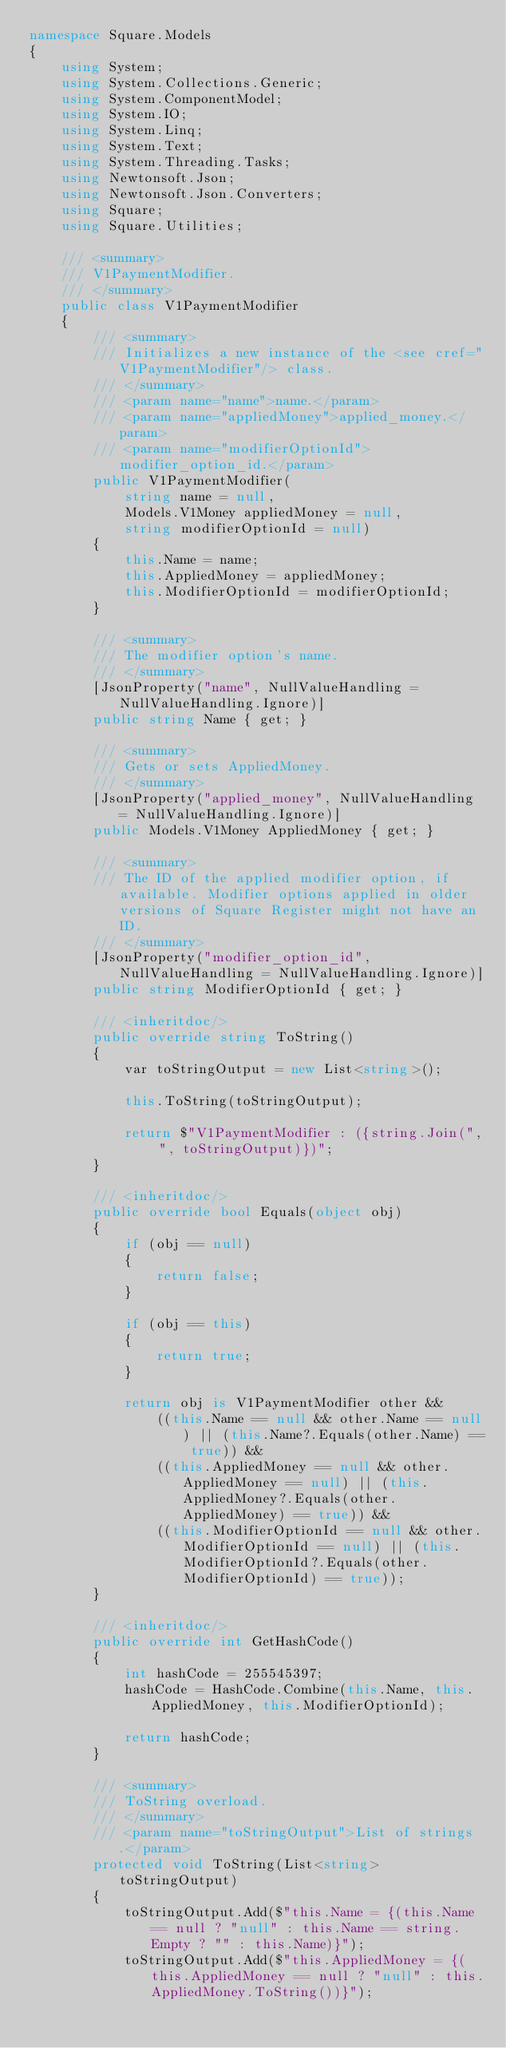Convert code to text. <code><loc_0><loc_0><loc_500><loc_500><_C#_>namespace Square.Models
{
    using System;
    using System.Collections.Generic;
    using System.ComponentModel;
    using System.IO;
    using System.Linq;
    using System.Text;
    using System.Threading.Tasks;
    using Newtonsoft.Json;
    using Newtonsoft.Json.Converters;
    using Square;
    using Square.Utilities;

    /// <summary>
    /// V1PaymentModifier.
    /// </summary>
    public class V1PaymentModifier
    {
        /// <summary>
        /// Initializes a new instance of the <see cref="V1PaymentModifier"/> class.
        /// </summary>
        /// <param name="name">name.</param>
        /// <param name="appliedMoney">applied_money.</param>
        /// <param name="modifierOptionId">modifier_option_id.</param>
        public V1PaymentModifier(
            string name = null,
            Models.V1Money appliedMoney = null,
            string modifierOptionId = null)
        {
            this.Name = name;
            this.AppliedMoney = appliedMoney;
            this.ModifierOptionId = modifierOptionId;
        }

        /// <summary>
        /// The modifier option's name.
        /// </summary>
        [JsonProperty("name", NullValueHandling = NullValueHandling.Ignore)]
        public string Name { get; }

        /// <summary>
        /// Gets or sets AppliedMoney.
        /// </summary>
        [JsonProperty("applied_money", NullValueHandling = NullValueHandling.Ignore)]
        public Models.V1Money AppliedMoney { get; }

        /// <summary>
        /// The ID of the applied modifier option, if available. Modifier options applied in older versions of Square Register might not have an ID.
        /// </summary>
        [JsonProperty("modifier_option_id", NullValueHandling = NullValueHandling.Ignore)]
        public string ModifierOptionId { get; }

        /// <inheritdoc/>
        public override string ToString()
        {
            var toStringOutput = new List<string>();

            this.ToString(toStringOutput);

            return $"V1PaymentModifier : ({string.Join(", ", toStringOutput)})";
        }

        /// <inheritdoc/>
        public override bool Equals(object obj)
        {
            if (obj == null)
            {
                return false;
            }

            if (obj == this)
            {
                return true;
            }

            return obj is V1PaymentModifier other &&
                ((this.Name == null && other.Name == null) || (this.Name?.Equals(other.Name) == true)) &&
                ((this.AppliedMoney == null && other.AppliedMoney == null) || (this.AppliedMoney?.Equals(other.AppliedMoney) == true)) &&
                ((this.ModifierOptionId == null && other.ModifierOptionId == null) || (this.ModifierOptionId?.Equals(other.ModifierOptionId) == true));
        }
        
        /// <inheritdoc/>
        public override int GetHashCode()
        {
            int hashCode = 255545397;
            hashCode = HashCode.Combine(this.Name, this.AppliedMoney, this.ModifierOptionId);

            return hashCode;
        }
  
        /// <summary>
        /// ToString overload.
        /// </summary>
        /// <param name="toStringOutput">List of strings.</param>
        protected void ToString(List<string> toStringOutput)
        {
            toStringOutput.Add($"this.Name = {(this.Name == null ? "null" : this.Name == string.Empty ? "" : this.Name)}");
            toStringOutput.Add($"this.AppliedMoney = {(this.AppliedMoney == null ? "null" : this.AppliedMoney.ToString())}");</code> 